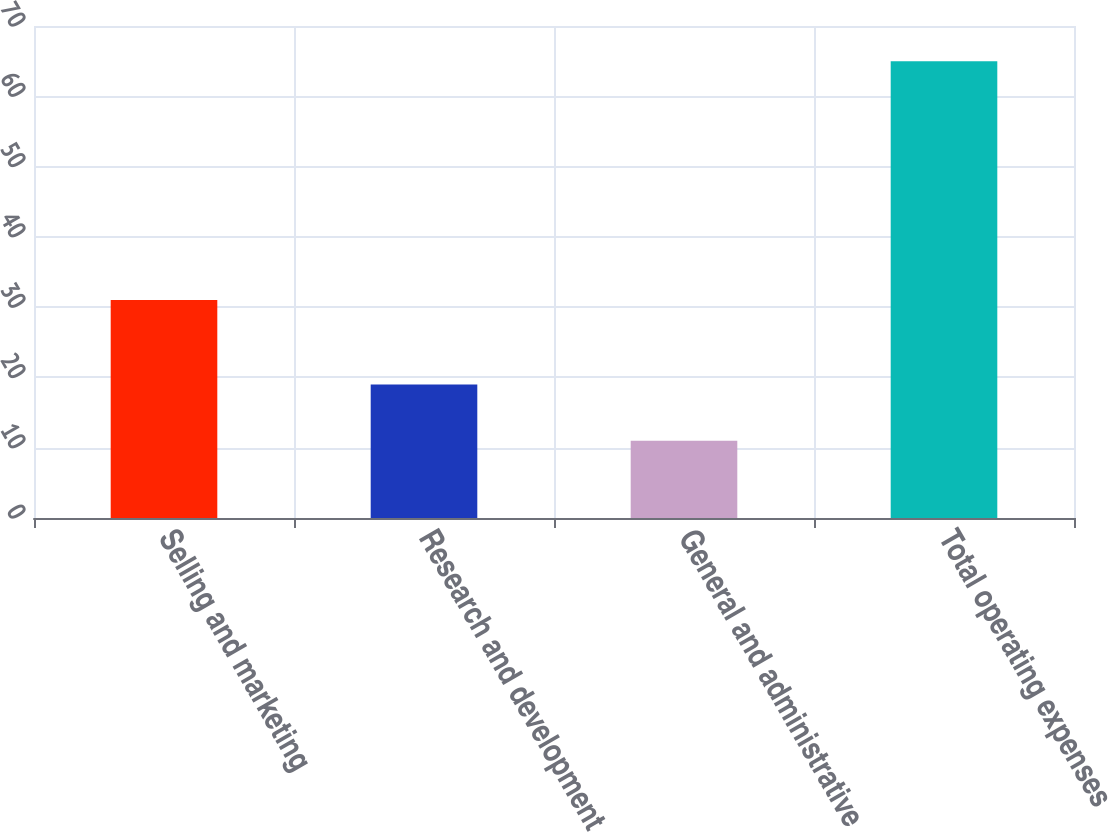Convert chart. <chart><loc_0><loc_0><loc_500><loc_500><bar_chart><fcel>Selling and marketing<fcel>Research and development<fcel>General and administrative<fcel>Total operating expenses<nl><fcel>31<fcel>19<fcel>11<fcel>65<nl></chart> 